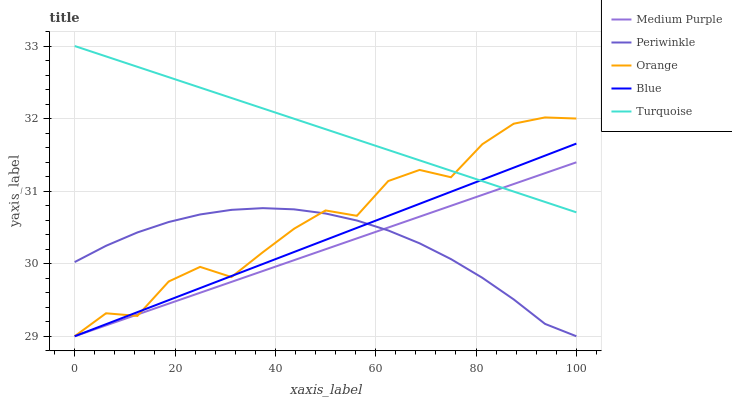Does Medium Purple have the minimum area under the curve?
Answer yes or no. Yes. Does Turquoise have the maximum area under the curve?
Answer yes or no. Yes. Does Orange have the minimum area under the curve?
Answer yes or no. No. Does Orange have the maximum area under the curve?
Answer yes or no. No. Is Turquoise the smoothest?
Answer yes or no. Yes. Is Orange the roughest?
Answer yes or no. Yes. Is Orange the smoothest?
Answer yes or no. No. Is Turquoise the roughest?
Answer yes or no. No. Does Turquoise have the lowest value?
Answer yes or no. No. Does Orange have the highest value?
Answer yes or no. No. Is Periwinkle less than Turquoise?
Answer yes or no. Yes. Is Turquoise greater than Periwinkle?
Answer yes or no. Yes. Does Periwinkle intersect Turquoise?
Answer yes or no. No. 